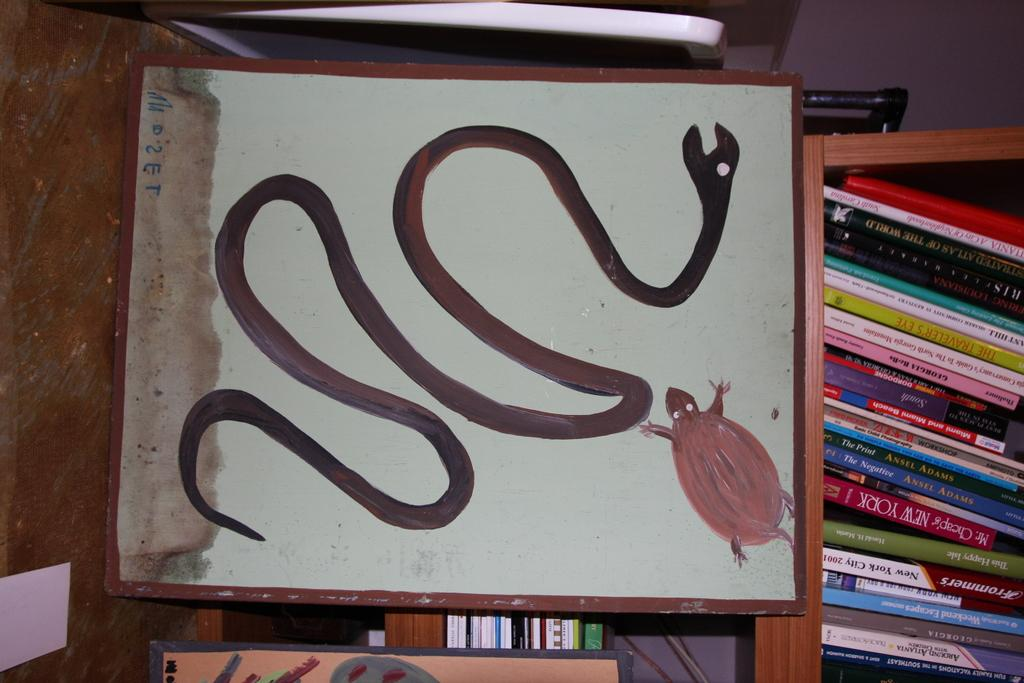What type of animals are depicted on the cardboard in the image? There is a drawing of a snake and an insect on the cardboard in the image. Where are the books located in the image? The books are on a wooden shelf on the right side of the image. What type of building is visible in the image? There is no building visible in the image; it only shows a cardboard with drawings and a wooden shelf with books. 